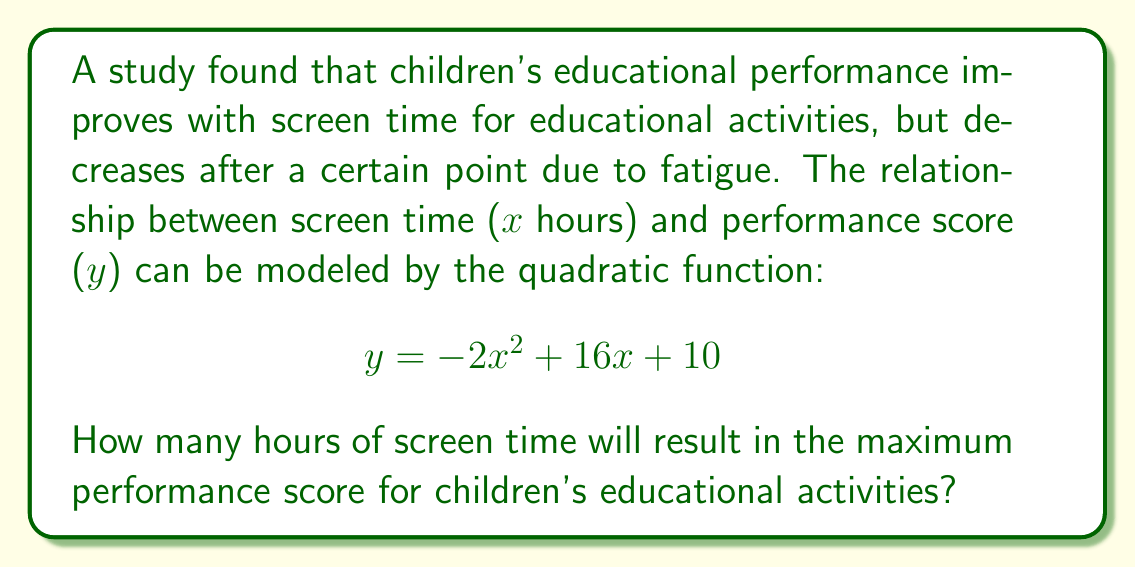Provide a solution to this math problem. To find the optimal screen time, we need to determine the maximum point of the quadratic function. We can do this by following these steps:

1) The quadratic function is in the form $y = ax^2 + bx + c$, where:
   $a = -2$, $b = 16$, and $c = 10$

2) For a quadratic function, the x-coordinate of the vertex (which represents the optimal point) is given by the formula:

   $$ x = -\frac{b}{2a} $$

3) Substituting our values:

   $$ x = -\frac{16}{2(-2)} = -\frac{16}{-4} = 4 $$

4) Therefore, the optimal screen time occurs at x = 4 hours.

5) We can verify this by calculating the y-value at x = 4:

   $$ y = -2(4)^2 + 16(4) + 10 $$
   $$ = -2(16) + 64 + 10 $$
   $$ = -32 + 64 + 10 = 42 $$

   This is indeed the maximum y-value (performance score) for this function.
Answer: 4 hours 